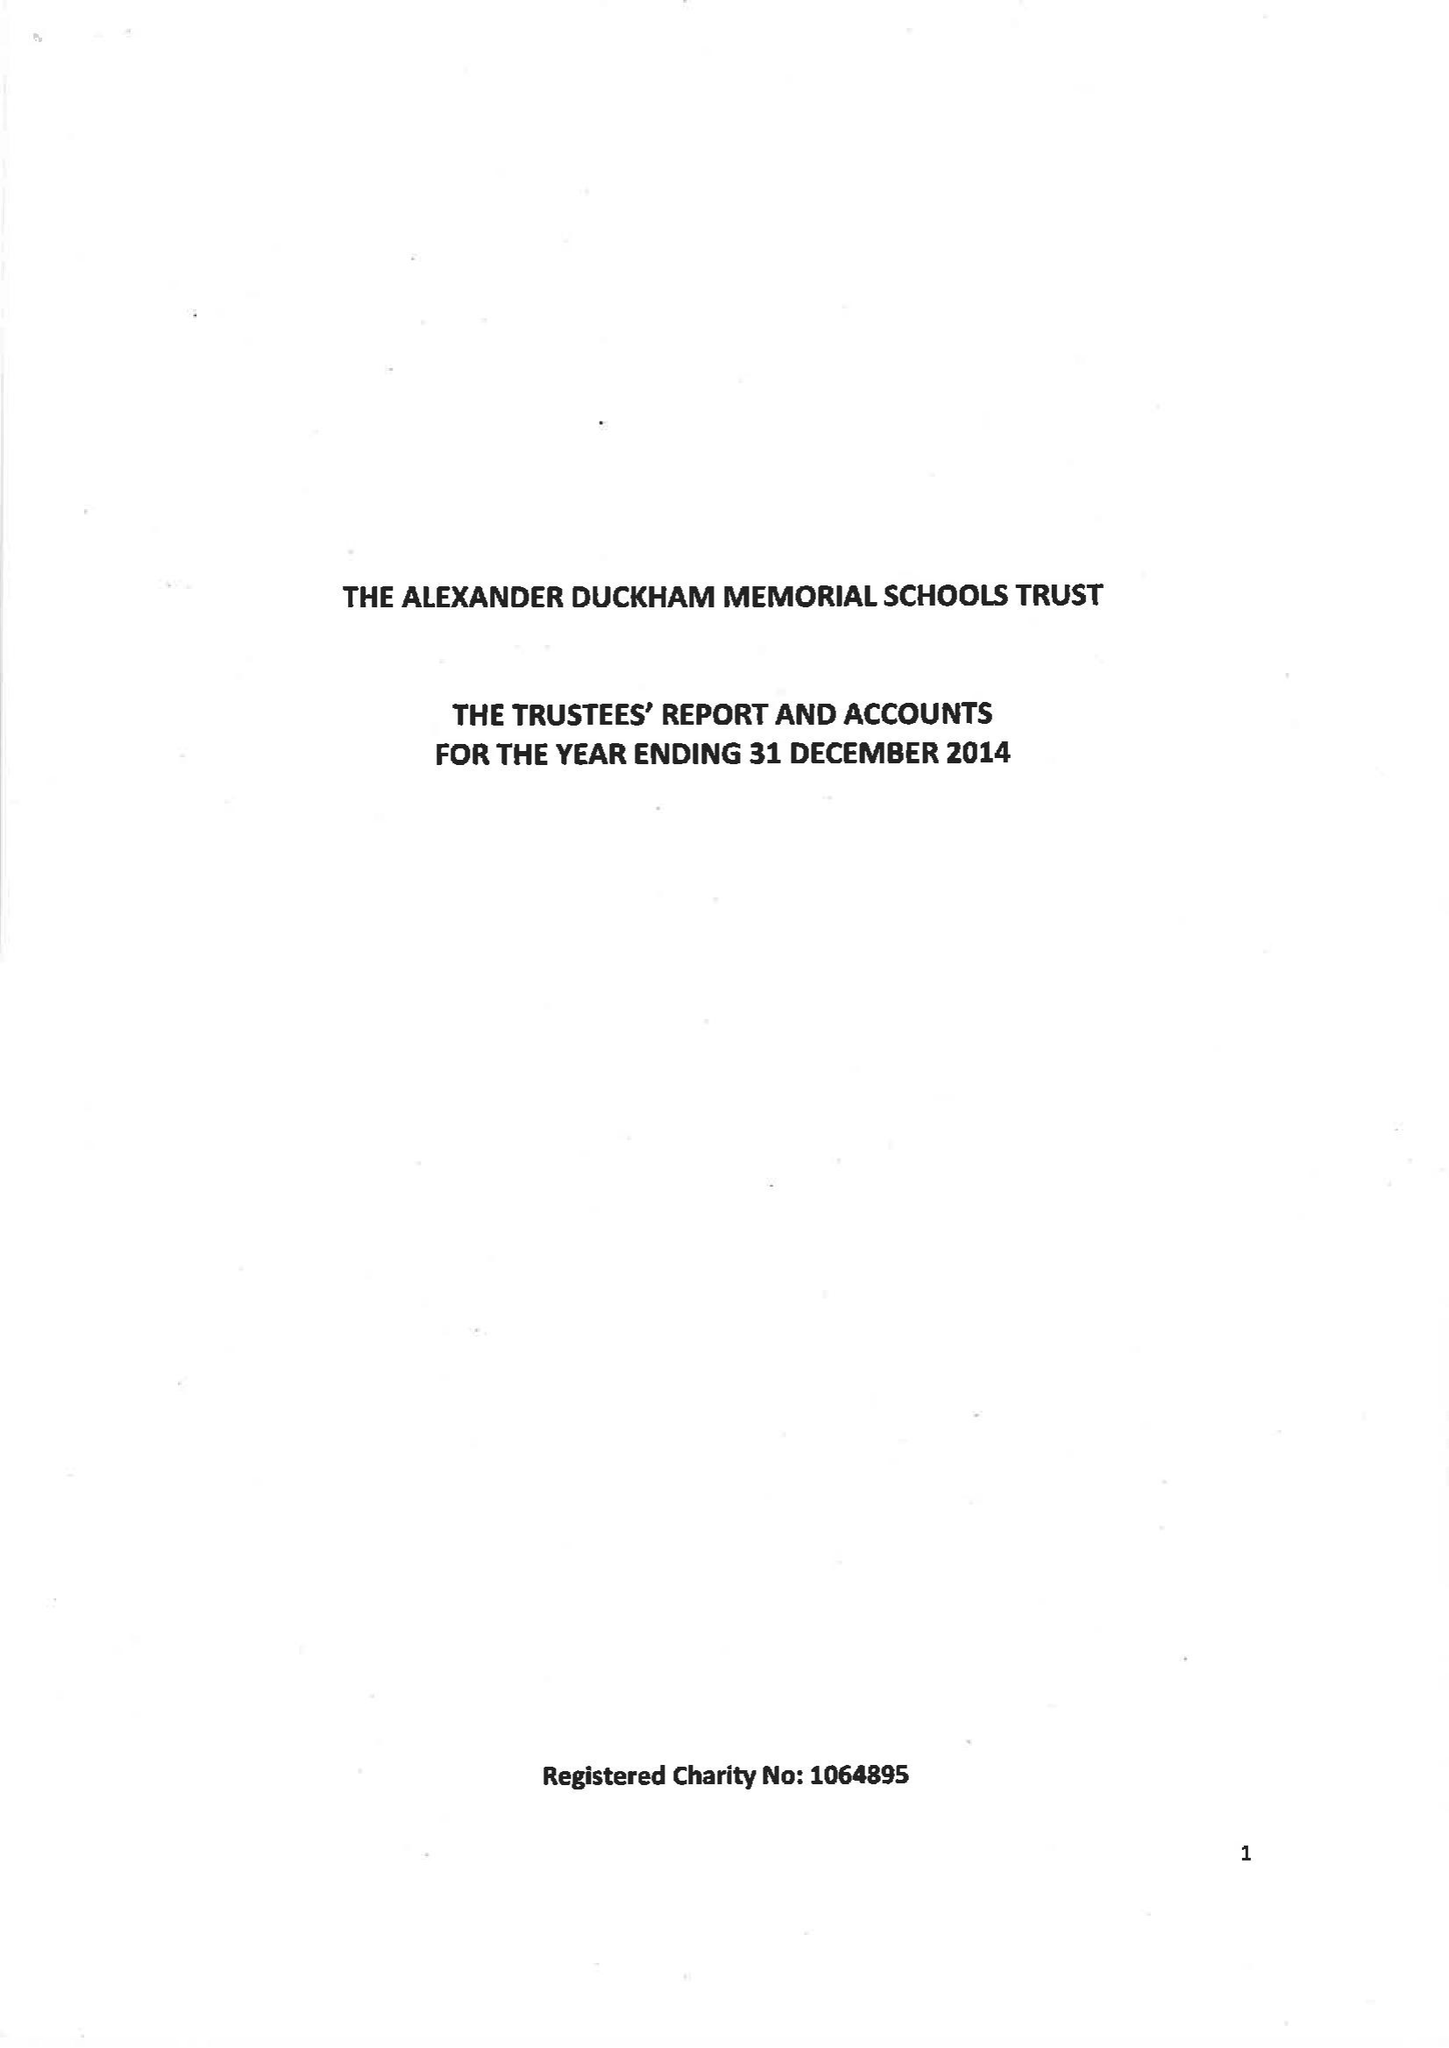What is the value for the address__postcode?
Answer the question using a single word or phrase. SW15 6RU 